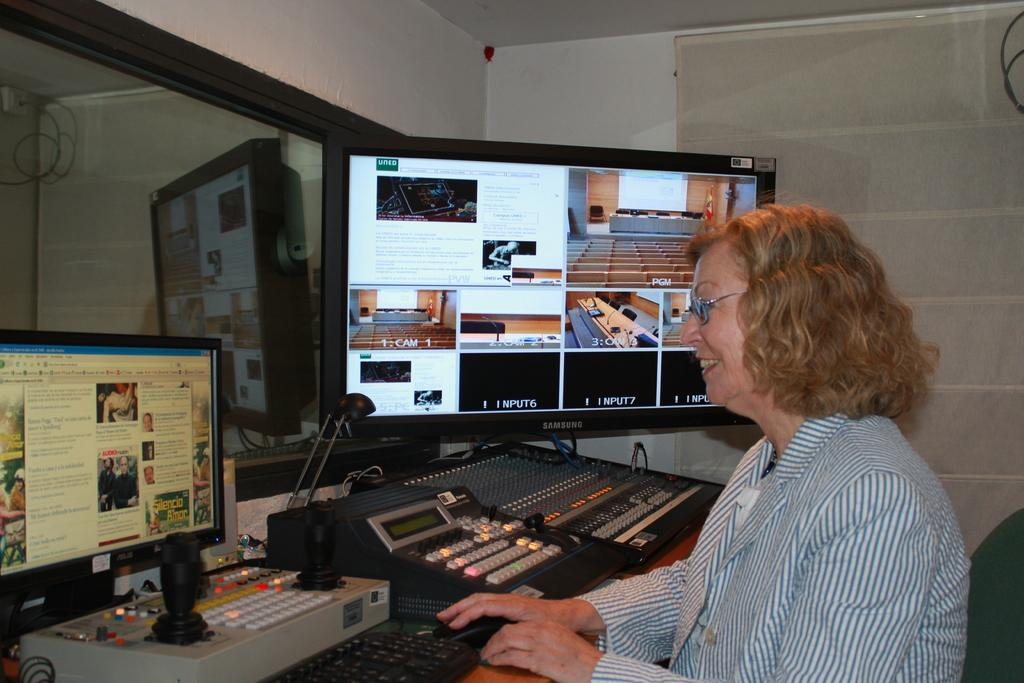<image>
Summarize the visual content of the image. a woman in front of two computer screens  with one having the words '1: CAM 1' on it 